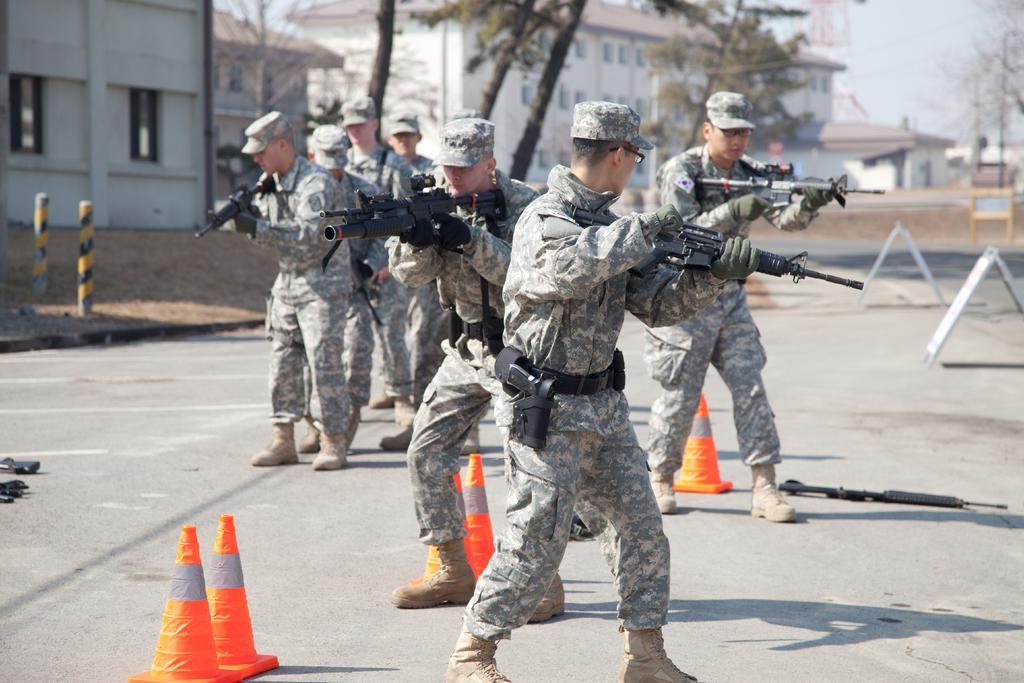Can you describe this image briefly? In the picture we can see some army people are standing on the road with guns, and wearing a uniform with caps and in the background we can see some buildings, trees, and sky. 